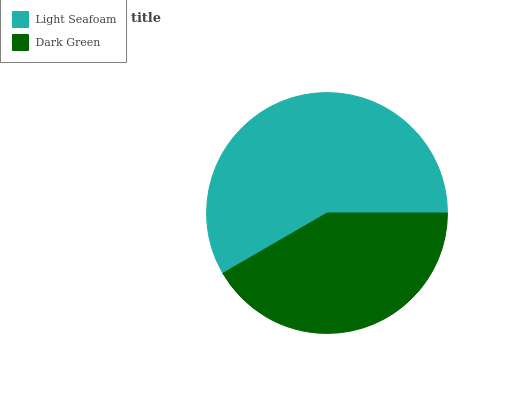Is Dark Green the minimum?
Answer yes or no. Yes. Is Light Seafoam the maximum?
Answer yes or no. Yes. Is Dark Green the maximum?
Answer yes or no. No. Is Light Seafoam greater than Dark Green?
Answer yes or no. Yes. Is Dark Green less than Light Seafoam?
Answer yes or no. Yes. Is Dark Green greater than Light Seafoam?
Answer yes or no. No. Is Light Seafoam less than Dark Green?
Answer yes or no. No. Is Light Seafoam the high median?
Answer yes or no. Yes. Is Dark Green the low median?
Answer yes or no. Yes. Is Dark Green the high median?
Answer yes or no. No. Is Light Seafoam the low median?
Answer yes or no. No. 